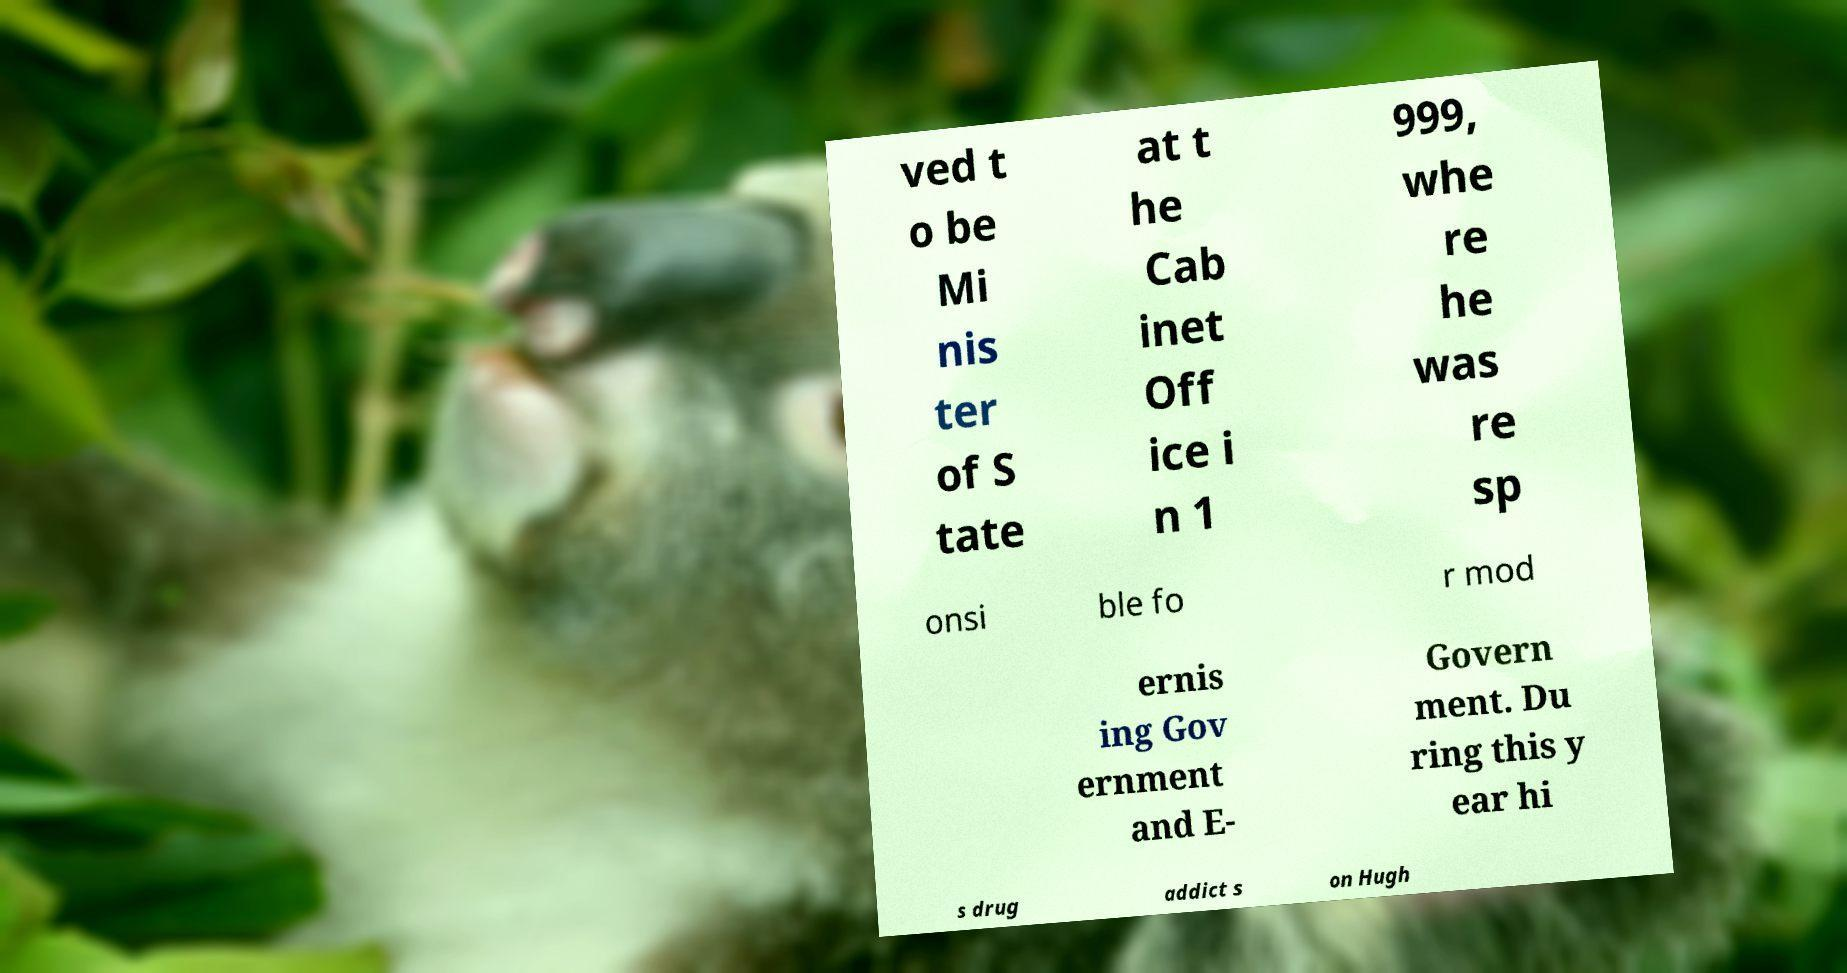What messages or text are displayed in this image? I need them in a readable, typed format. ved t o be Mi nis ter of S tate at t he Cab inet Off ice i n 1 999, whe re he was re sp onsi ble fo r mod ernis ing Gov ernment and E- Govern ment. Du ring this y ear hi s drug addict s on Hugh 